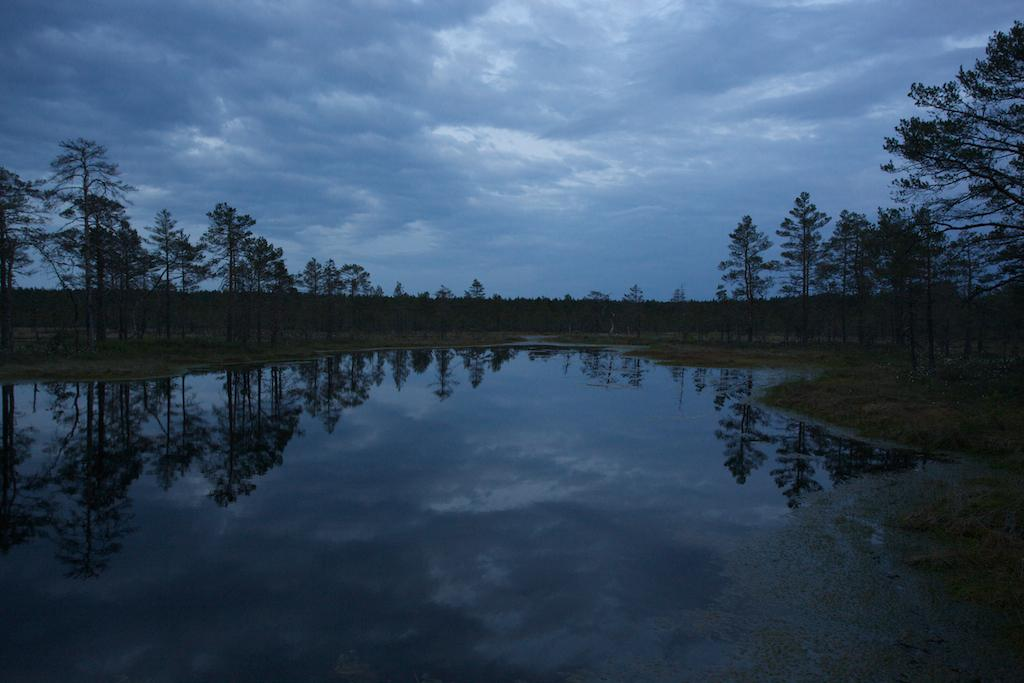What is the primary element in the image? There is water in the image. What can be seen in the background of the image? There is land visible in the background of the image. What type of vegetation is present in the image? There are trees on the ground. What is visible at the top of the image? The sky is visible at the top of the image. What is present at the bottom right corner of the water? There is algae in the bottom right corner of the water. Who is the governor in the image? There is no governor present in the image. What type of pest can be seen in the image? There are no pests visible in the image. 